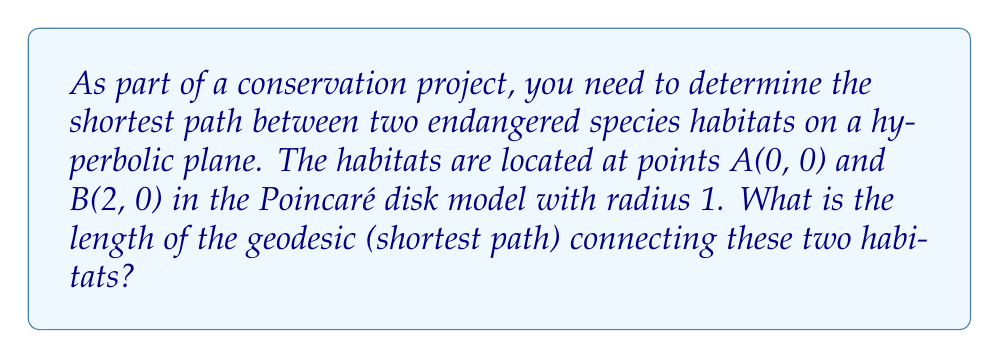Solve this math problem. To solve this problem, we'll follow these steps:

1. Recall that in the Poincaré disk model, geodesics are either diameters or circular arcs perpendicular to the boundary circle.

2. Since both points lie on the x-axis, the geodesic is a diameter of the disk.

3. The hyperbolic distance $d$ between two points $(x_1, y_1)$ and $(x_2, y_2)$ in the Poincaré disk model is given by:

   $$d = \text{arcosh}\left(1 + \frac{2(x_2 - x_1)^2 + 2(y_2 - y_1)^2}{(1 - x_1^2 - y_1^2)(1 - x_2^2 - y_2^2)}\right)$$

4. Substitute the coordinates: A(0, 0) and B(2, 0):

   $$d = \text{arcosh}\left(1 + \frac{2(2 - 0)^2 + 2(0 - 0)^2}{(1 - 0^2 - 0^2)(1 - 2^2 - 0^2)}\right)$$

5. Simplify:

   $$d = \text{arcosh}\left(1 + \frac{8}{1 \cdot (-3)}\right) = \text{arcosh}\left(1 - \frac{8}{3}\right)$$

6. Calculate the final result:

   $$d = \text{arcosh}\left(-\frac{5}{3}\right)$$

This is the length of the geodesic connecting the two habitats in the hyperbolic plane.

[asy]
import geometry;

unitsize(100);
draw(circle((0,0),1));
dot((0,0));
dot((2,0));
draw((0,0)--(2,0),blue);
label("A", (0,0), SW);
label("B", (2,0), SE);
[/asy]
Answer: $\text{arcosh}\left(-\frac{5}{3}\right)$ 